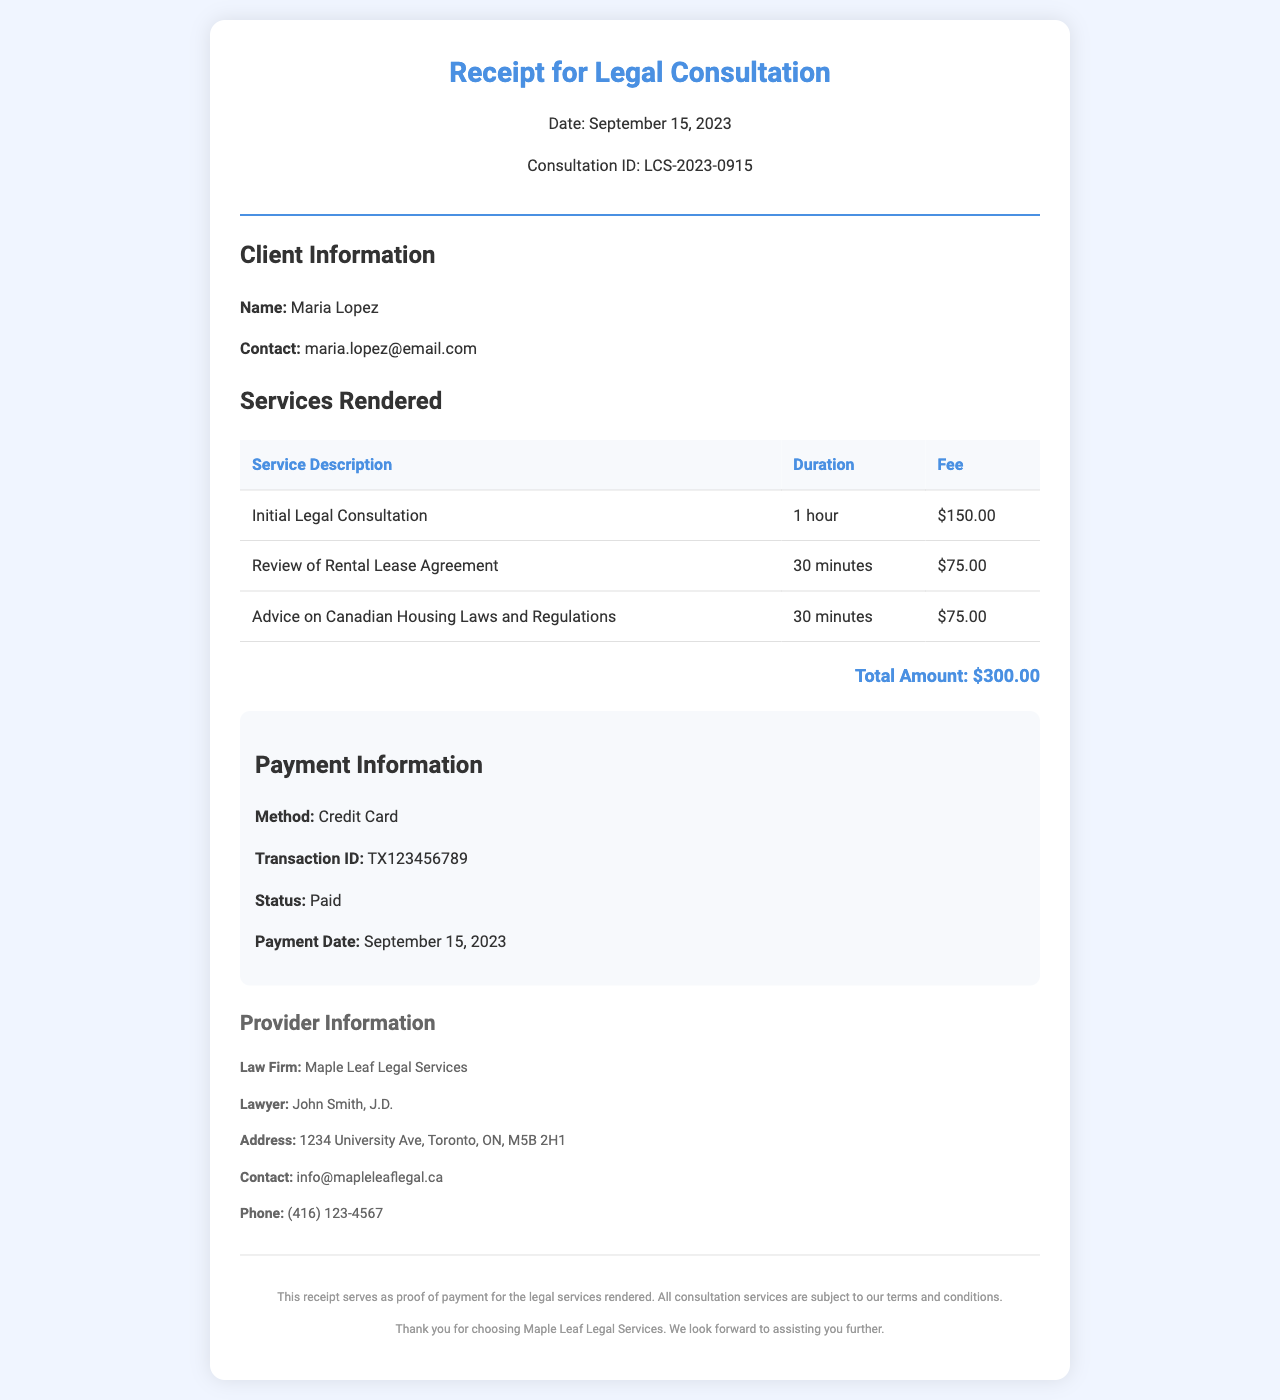What is the date of the consultation? The date of the consultation is specifically mentioned in the header of the receipt as September 15, 2023.
Answer: September 15, 2023 Who is the client? The client's name is presented in the client information section of the receipt.
Answer: Maria Lopez What is the total amount charged? The total amount appears in the services rendered section as the sum of all fees.
Answer: $300.00 What method was used for payment? The payment information section specifies the payment method used for the transaction.
Answer: Credit Card How much was charged for the initial legal consultation? The fee for the initial legal consultation is listed in the services rendered table.
Answer: $150.00 What is the transaction ID? The transaction ID is noted in the payment information section of the receipt.
Answer: TX123456789 How long was the review of the rental lease agreement? The duration for the review of the rental lease agreement is indicated in the services rendered table.
Answer: 30 minutes What is the provider's contact email? The contact email for the law firm is provided in the provider information section.
Answer: info@mapleleaflegal.ca Who provided the legal consultation? The name of the lawyer is mentioned in the provider information section of the receipt.
Answer: John Smith, J.D 